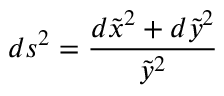<formula> <loc_0><loc_0><loc_500><loc_500>d s ^ { 2 } = \frac { d \tilde { x } ^ { 2 } + d \tilde { y } ^ { 2 } } { \tilde { y } ^ { 2 } }</formula> 